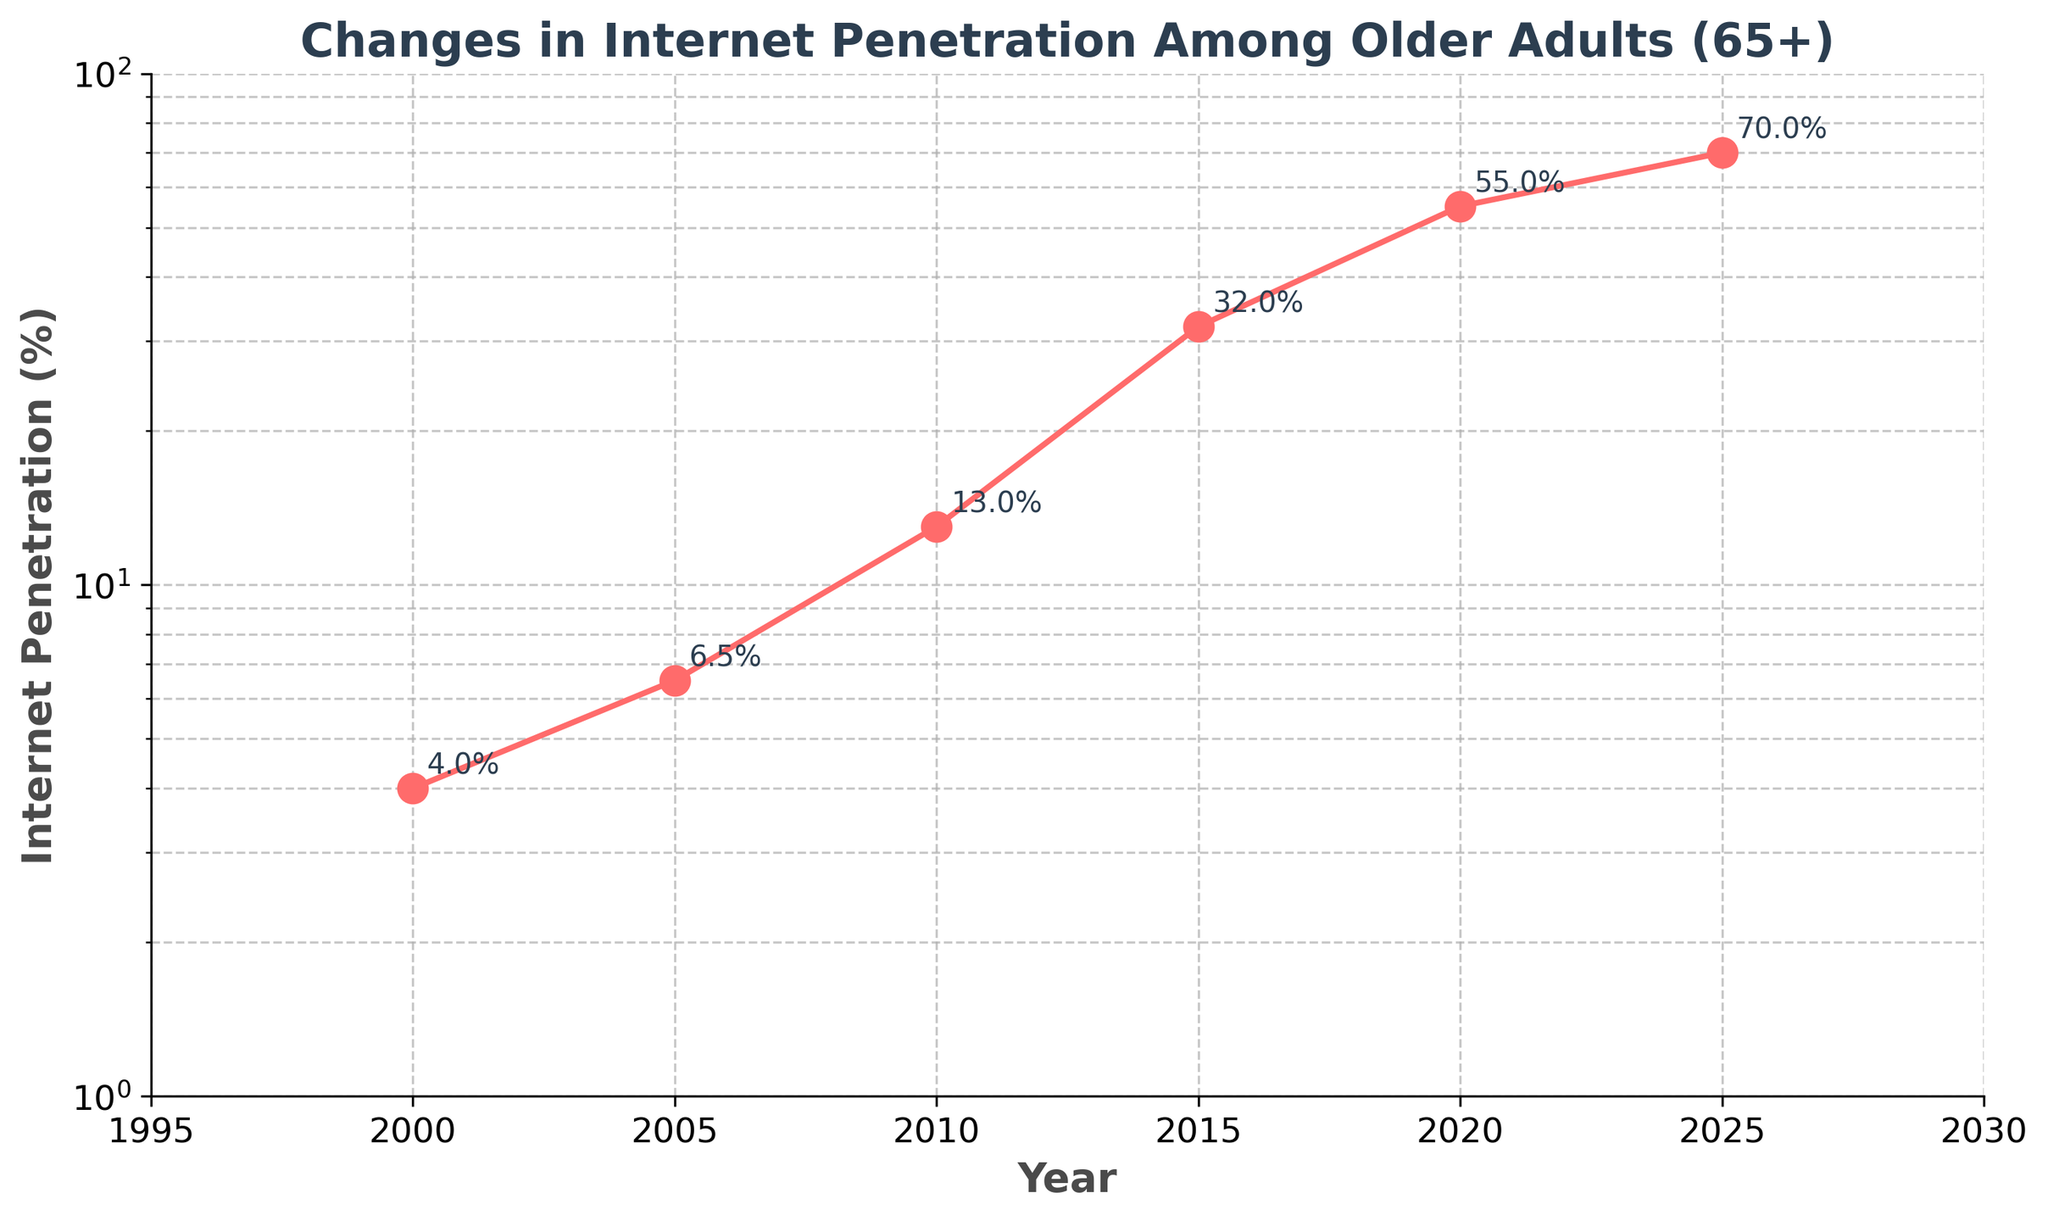What is the title of the figure? The title of the figure is usually placed at the top of the plot. In this case, the title reads: "Changes in Internet Penetration Among Older Adults (65+)".
Answer: Changes in Internet Penetration Among Older Adults (65+) What are the x-axis and y-axis labels? The x-axis label is "Year" which can be seen at the bottom of the plot, and the y-axis label is "Internet Penetration (%)" which is placed along the left side of the plot.
Answer: Year and Internet Penetration (%) How many data points are shown in the plot? There are markers shown on the plot for each year where data is available: 2000, 2005, 2010, 2015, 2020, and 2025. By counting these markers, we find there are 6 data points.
Answer: 6 What is the internet penetration percentage in the year 2010? To find this, look for the point on the plot corresponding to the year 2010. The point's label indicates the penetration percentage. It shows 13%.
Answer: 13% Between which two consecutive years did internet penetration among older adults increase the most? To answer this, compare the increments between each consecutive data point. The changes are: from 2000 to 2005, 2.5%, from 2005 to 2010, 6.5%, from 2010 to 2015, 19%, from 2015 to 2020, 23%, and from 2020 to 2025, 15%. Thus, the biggest increase (23%) occurred between 2015 and 2020.
Answer: 2015 and 2020 By what percentage did internet penetration among older adults increase from 2000 to 2020? The penetration was 4% in 2000 and 55% in 2020. The increase can be calculated by subtracting the initial value from the final value (55 - 4), which is 51%.
Answer: 51% How does the internet penetration in 2005 compare to 2025? The penetration in 2005 is 6.5%. In 2025, it is 70%. 70% is significantly larger than 6.5%, indicating substantial growth over this period.
Answer: 2025 has a higher penetration What is the average internet penetration from the available years? Summing up the penetration values (4 + 6.5 + 13 + 32 + 55 + 70) gives 180.5. Dividing by the number of data points (6) gives an average of 30.08%.
Answer: 30.08% What range of internet penetration percentages is represented on the y-axis? The y-axis ranges from 1% to 100% which can be observed from the axis limits and tick marks on the plot.
Answer: 1% to 100% Why is a log scale used for the y-axis? A log scale is used to better visualize data that spans several orders of magnitude, making it easier to see both small and large changes in internet penetration. Deviations from this pattern would distort the visual readability of the trends over time.
Answer: Easier to see changes in data spanning several magnitudes 